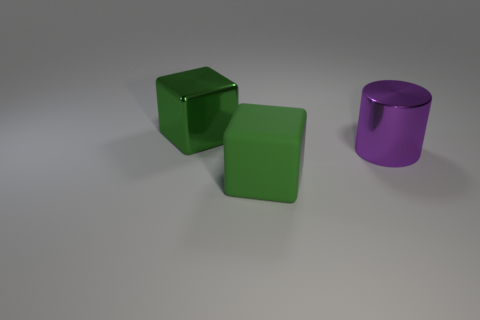Are there any metallic cylinders of the same color as the large rubber thing?
Provide a short and direct response. No. What is the shape of the matte object that is the same size as the green metal thing?
Your response must be concise. Cube. Are there fewer green objects than green matte cubes?
Your response must be concise. No. What number of other objects are the same size as the matte thing?
Keep it short and to the point. 2. What is the shape of the other big thing that is the same color as the matte thing?
Offer a very short reply. Cube. What material is the large purple cylinder?
Your answer should be compact. Metal. There is a green cube that is behind the large matte block; what size is it?
Offer a terse response. Large. How many other matte things are the same shape as the large green matte thing?
Ensure brevity in your answer.  0. How many red things are large shiny cylinders or cubes?
Keep it short and to the point. 0. Are there any rubber things behind the purple cylinder?
Offer a terse response. No. 